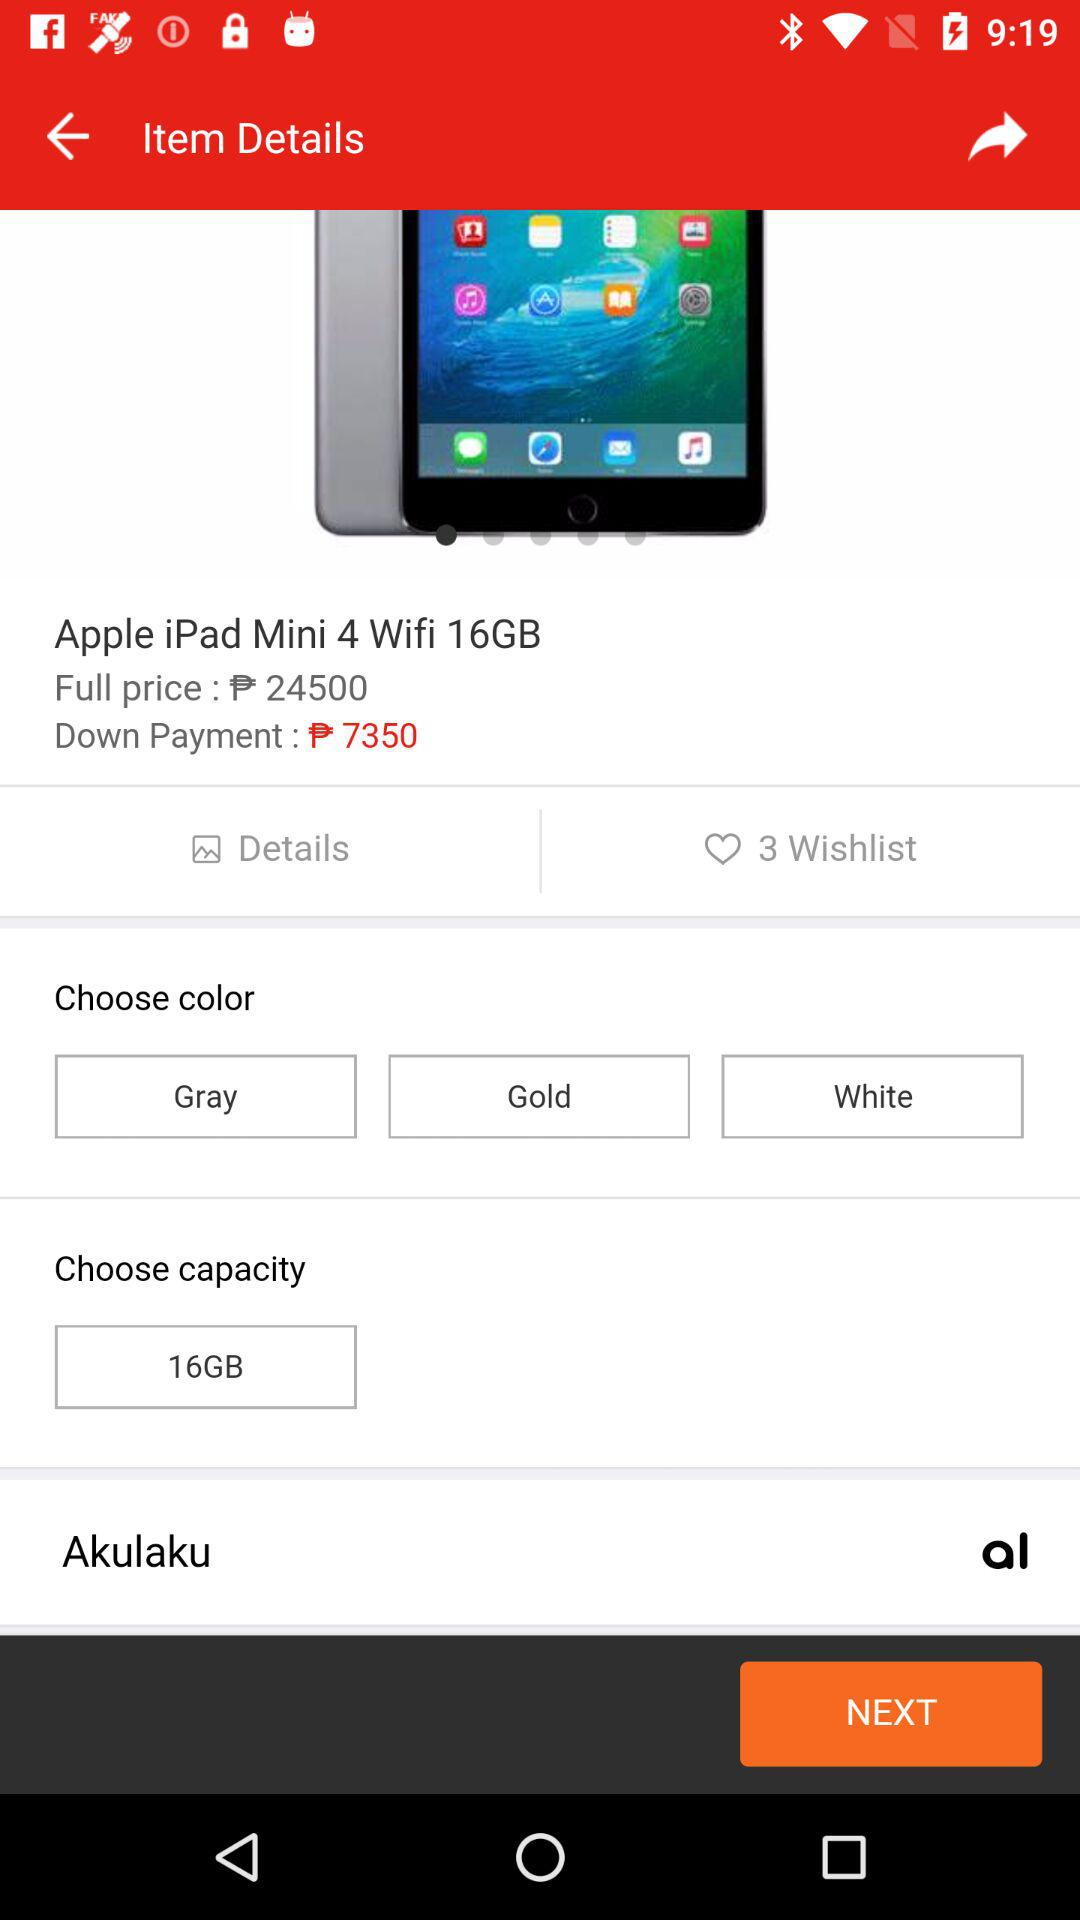How many items are there on the wishlist? There are 3 items on the wishlist. 